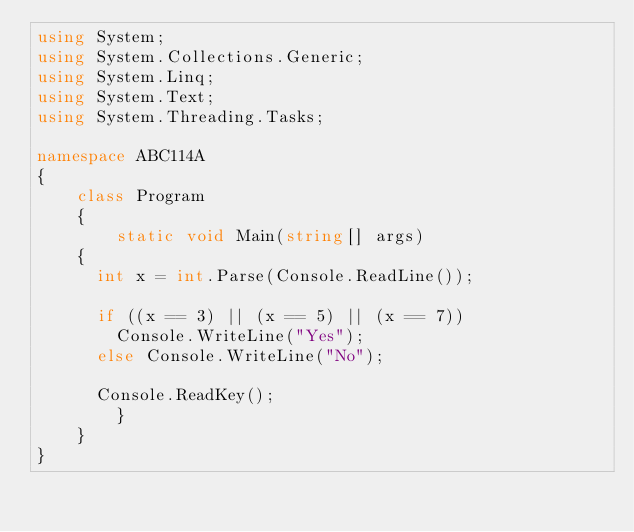<code> <loc_0><loc_0><loc_500><loc_500><_C#_>using System;
using System.Collections.Generic;
using System.Linq;
using System.Text;
using System.Threading.Tasks;

namespace ABC114A
{
    class Program
    {
        static void Main(string[] args)
		{
			int x = int.Parse(Console.ReadLine());

			if ((x == 3) || (x == 5) || (x == 7))
				Console.WriteLine("Yes");
			else Console.WriteLine("No");

			Console.ReadKey();
        }
    }
}</code> 